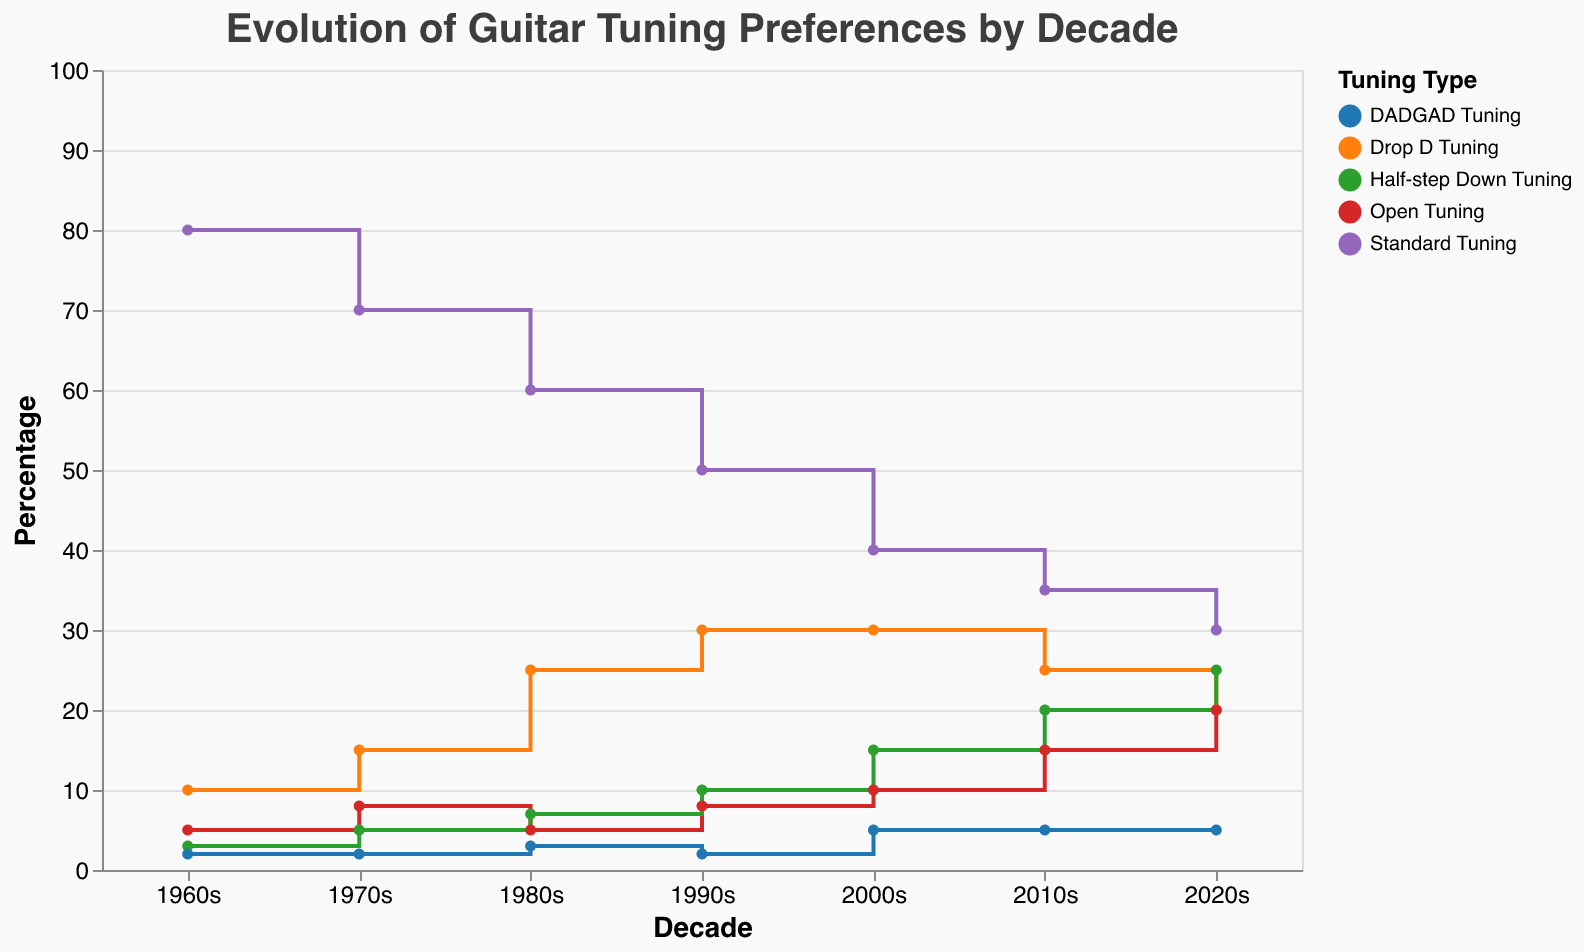what is the most popular guitar tuning type in the 1960s? In the 1960s, the line representing "Standard Tuning" is the highest on the y-axis at 80%. Therefore, "Standard Tuning" is the most popular.
Answer: Standard Tuning which decade had the highest percentage of Drop D Tuning? To find the decade, locate the peak of the "Drop D Tuning" line. The highest point (30%) appears in the 1990s and 2000s.
Answer: 1990s, 2000s how did the popularity of Half-step Down Tuning change from the 1960s to 2020s? In the 1960s, "Half-step Down Tuning" had a popularity of 3%. In the 2020s, it reached 25%. The popularity of Half-step Down Tuning increased steadily over the decades.
Answer: It increased what tunings had an equal percentage in the 2000s? In the 2000s, the y-values for "Drop D Tuning" and "Half-step Down Tuning" are both 30%.
Answer: Drop D Tuning, Half-step Down Tuning which tuning type shows a constant percentage from the 1980s to 2020s? The "DADGAD Tuning" line reads 2% in both the 1960s and 1970s, similarly dropping to 2% again in the 1990s and remaining at 5% since the 2000s.
Answer: DADGAD Tuning what is the percentage difference of Standard Tuning between the 1970s and 2010s? The y-values for "Standard Tuning" are 70% in the 1970s and 35% in the 2010s. Subtract the 2010s value from the 1970s value for the difference: 70% - 35% = 35%.
Answer: 35% which tuning type saw its rise and then a decline in percentages from the 1960s to the 2020s? "Drop D Tuning" increased from the 1960s to 2000s and then declined into the 2010s and 2020s.
Answer: Drop D Tuning in which decade did Open Tuning equal the percentage of Standard Tuning? In the 2020s, both "Standard Tuning" and "Open Tuning" share the same y-value of 30%.
Answer: 2020s what is the average percentage of Drop D Tuning across all the decades? Add the percentages of "Drop D Tuning" across the decades (10 + 15 + 25 + 30 + 30 + 25 + 20) = 155. Divide by the number of decades (7) to get the average: 155 / 7 ≈ 22.1%.
Answer: 22.1% 